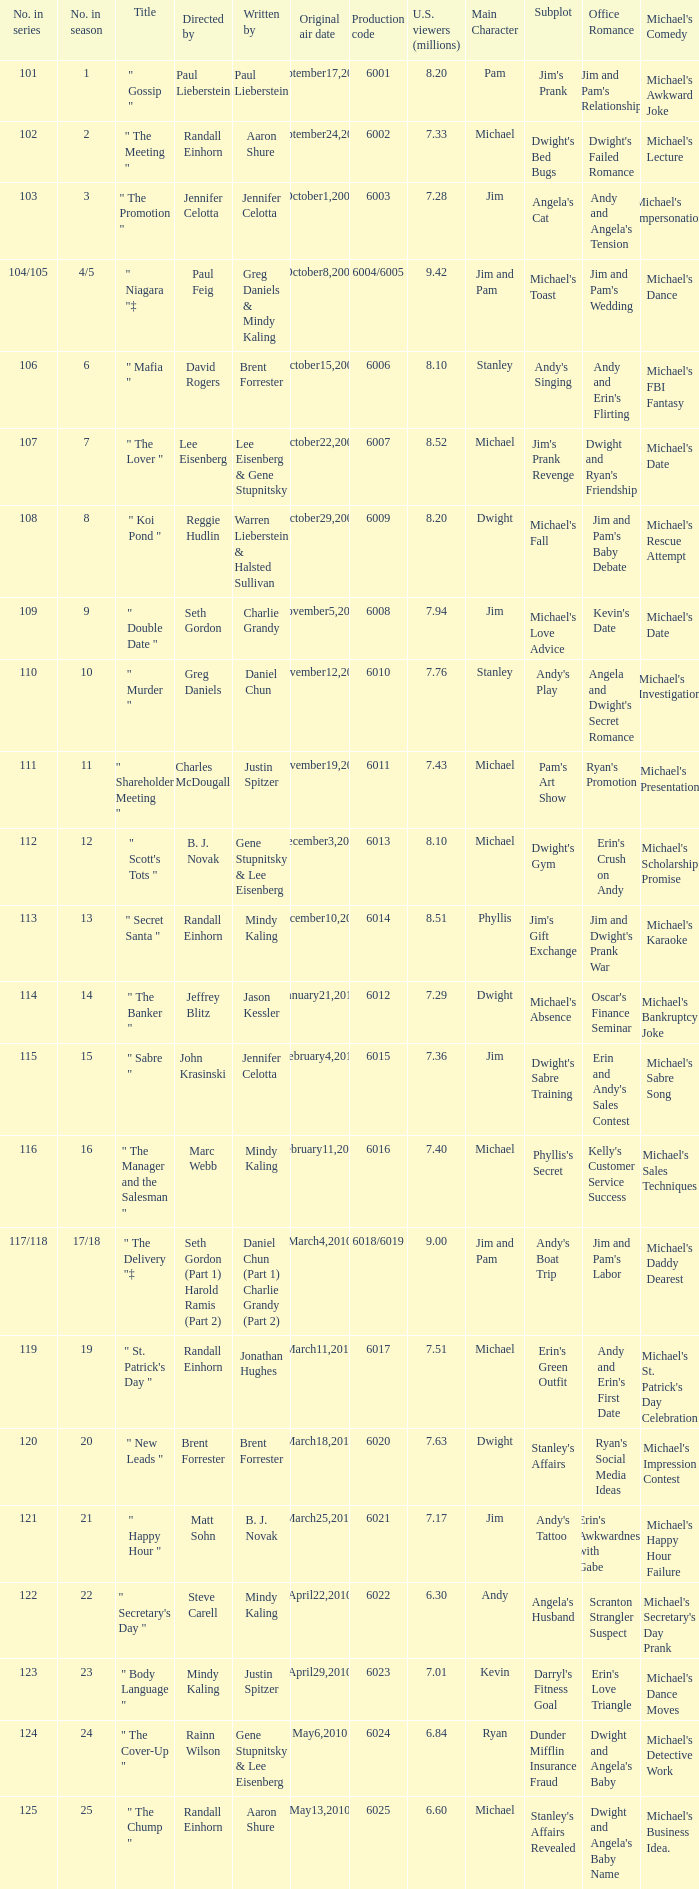Name the production code by paul lieberstein 6001.0. 